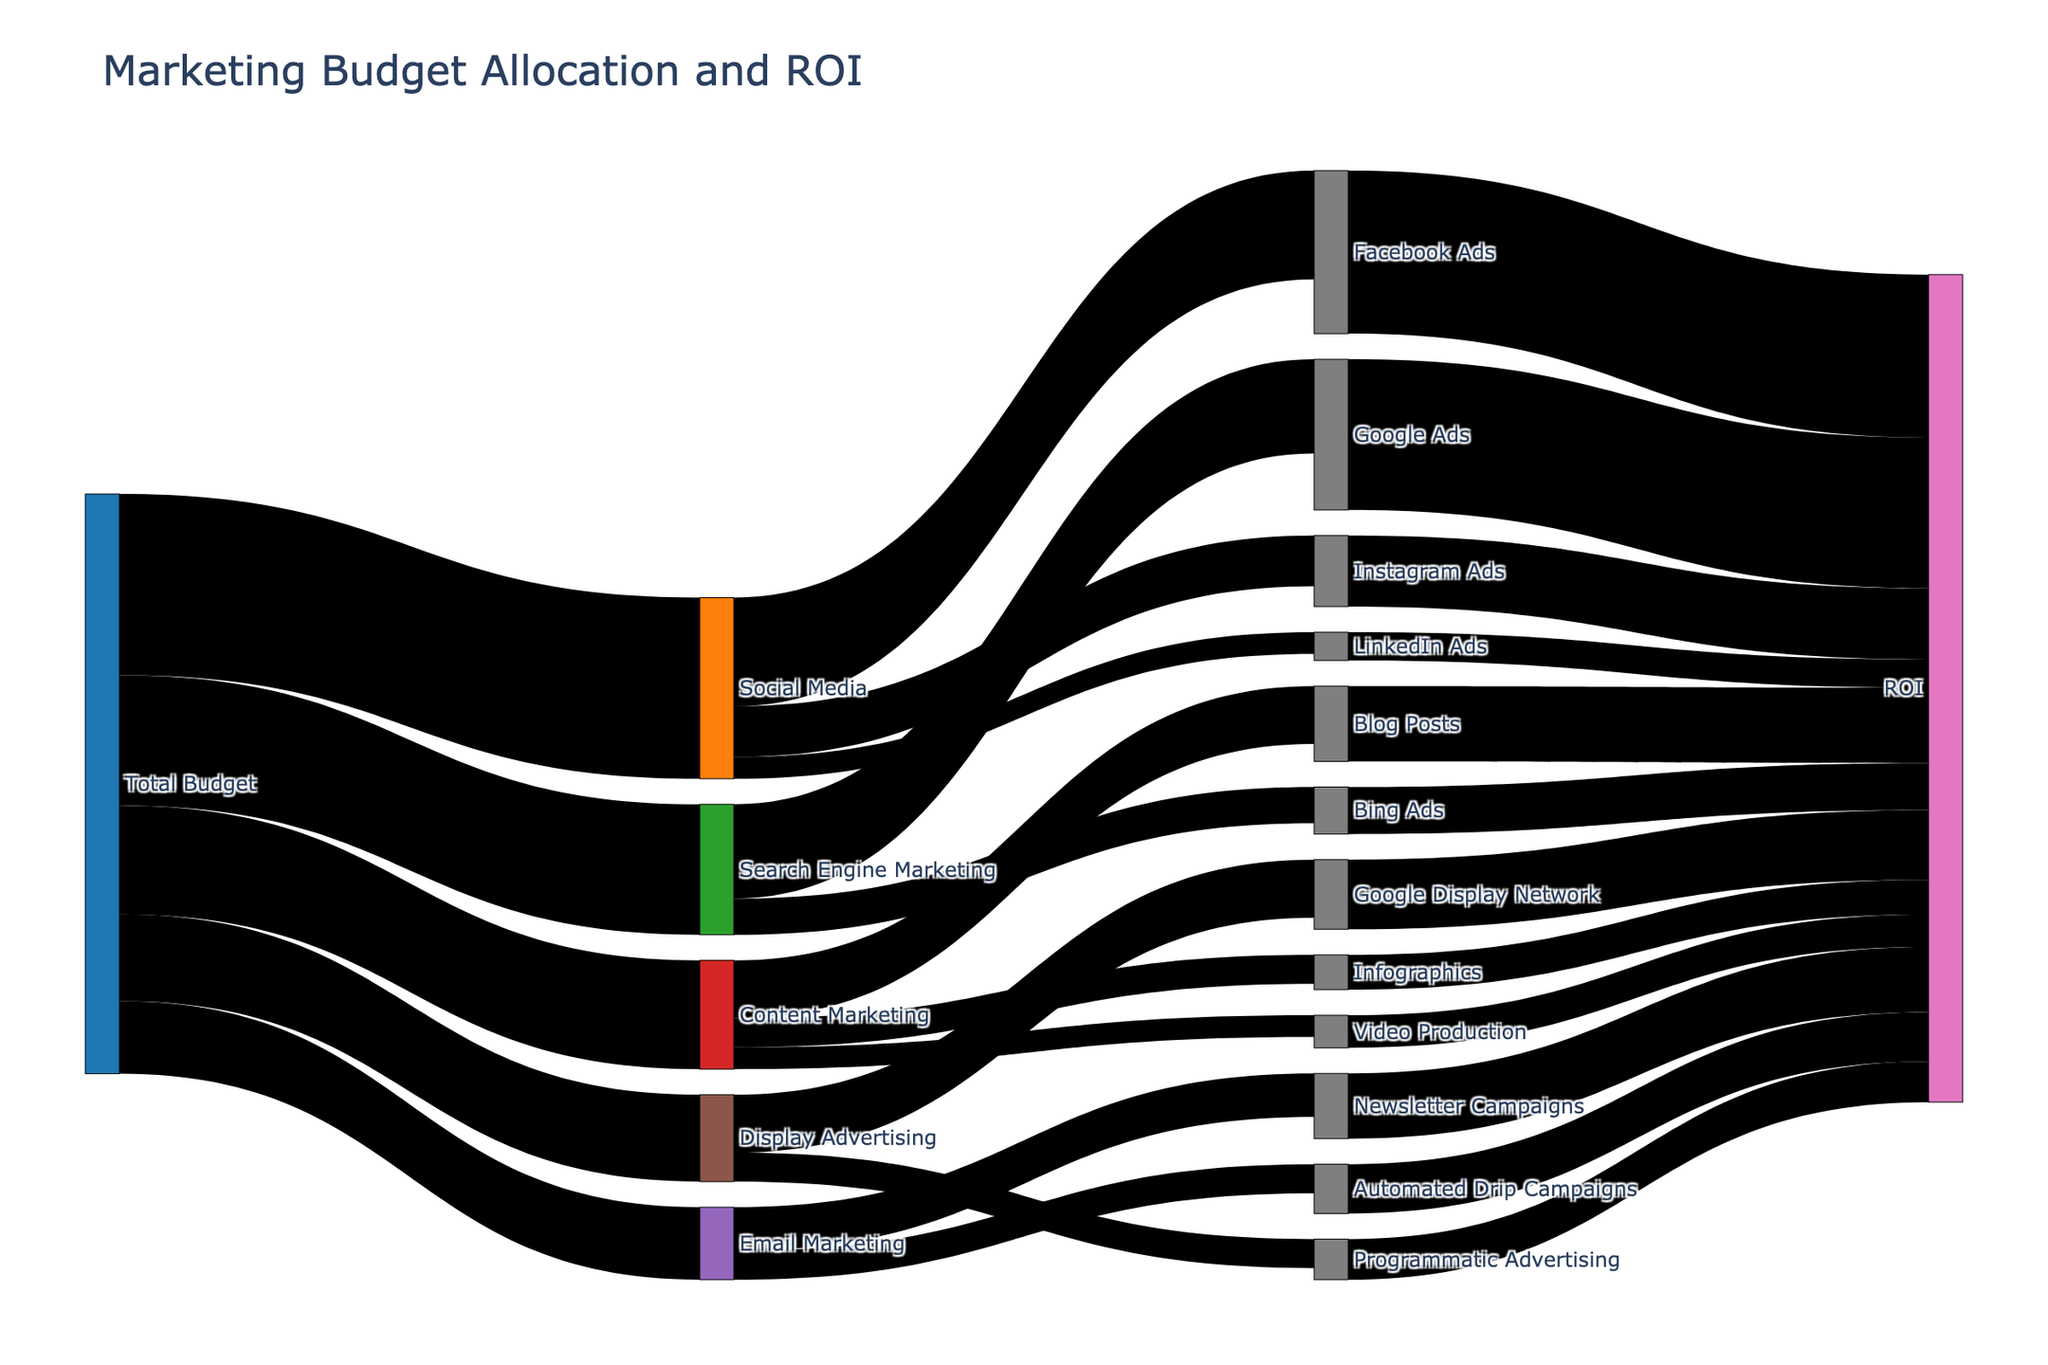What is the total budget allocated to Social Media? The total budget allocated to Social Media can be seen from the link between Total Budget and Social Media.
Answer: 250000 Which marketing channel received the lowest budget? By looking at the links from Total Budget to different marketing channels, the one with the lowest value indicates the lowest budget. Email Marketing received 100000, which is the lowest.
Answer: Email Marketing What is the ROI for Facebook Ads? The ROI for Facebook Ads is indicated in the figure where Facebook Ads links to ROI.
Answer: 225000 How much budget was allocated to Search Engine Marketing compared to Content Marketing? The budget for Search Engine Marketing is 180000 and for Content Marketing is 150000. By comparing these values, Search Engine Marketing received a higher budget.
Answer: 30000 more Which subcategory in Social Media has the highest ROI? The subcategory within Social Media with the highest ROI can be determined by comparing the ROI links from Facebook Ads, Instagram Ads, and LinkedIn Ads. Facebook Ads has the highest ROI of 225000.
Answer: Facebook Ads Determine the total ROI generated from Display Advertising subcategories? To find the total ROI from Display Advertising, sum the ROIs of Google Display Network and Programmatic Advertising. 96000 + 56000 = 152000.
Answer: 152000 What is the sum of budgets for all marketing channels? To sum the budgets for all marketing channels, add the values from Total Budget to each channel: 250000 + 180000 + 150000 + 100000 + 120000 = 800000.
Answer: 800000 Which channel has a higher ROI, Search Engine Marketing or Display Advertising? Compare the total ROI for Search Engine Marketing (Google Ads 208000 + Bing Ads 65000 = 273000) with Display Advertising (Google Display Network 96000 + Programmatic Advertising 56000 = 152000). Search Engine Marketing has a higher ROI.
Answer: Search Engine Marketing Calculate the difference in ROI between Google Ads and Bing Ads. Subtract the ROI of Bing Ads from Google Ads. 208000 - 65000 = 143000.
Answer: 143000 Which Email Marketing subcategory provides a higher return, Newsletter Campaigns or Automated Drip Campaigns? Compare the ROI of Newsletter Campaigns (90000) to Automated Drip Campaigns (68000); Newsletter Campaigns have a higher ROI.
Answer: Newsletter Campaigns 